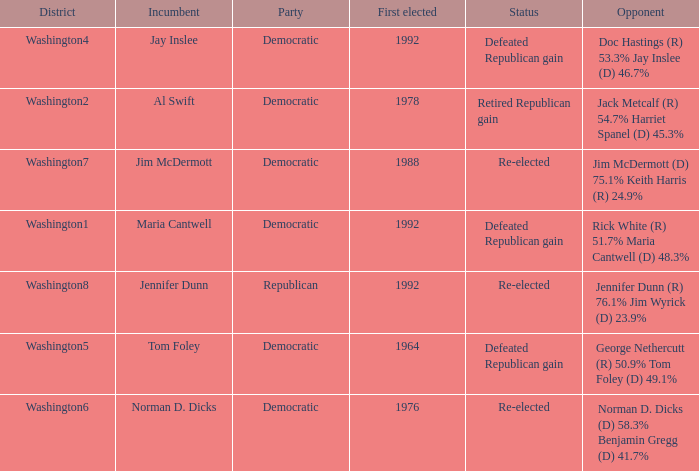What was the result of the election of doc hastings (r) 53.3% jay inslee (d) 46.7% Defeated Republican gain. 